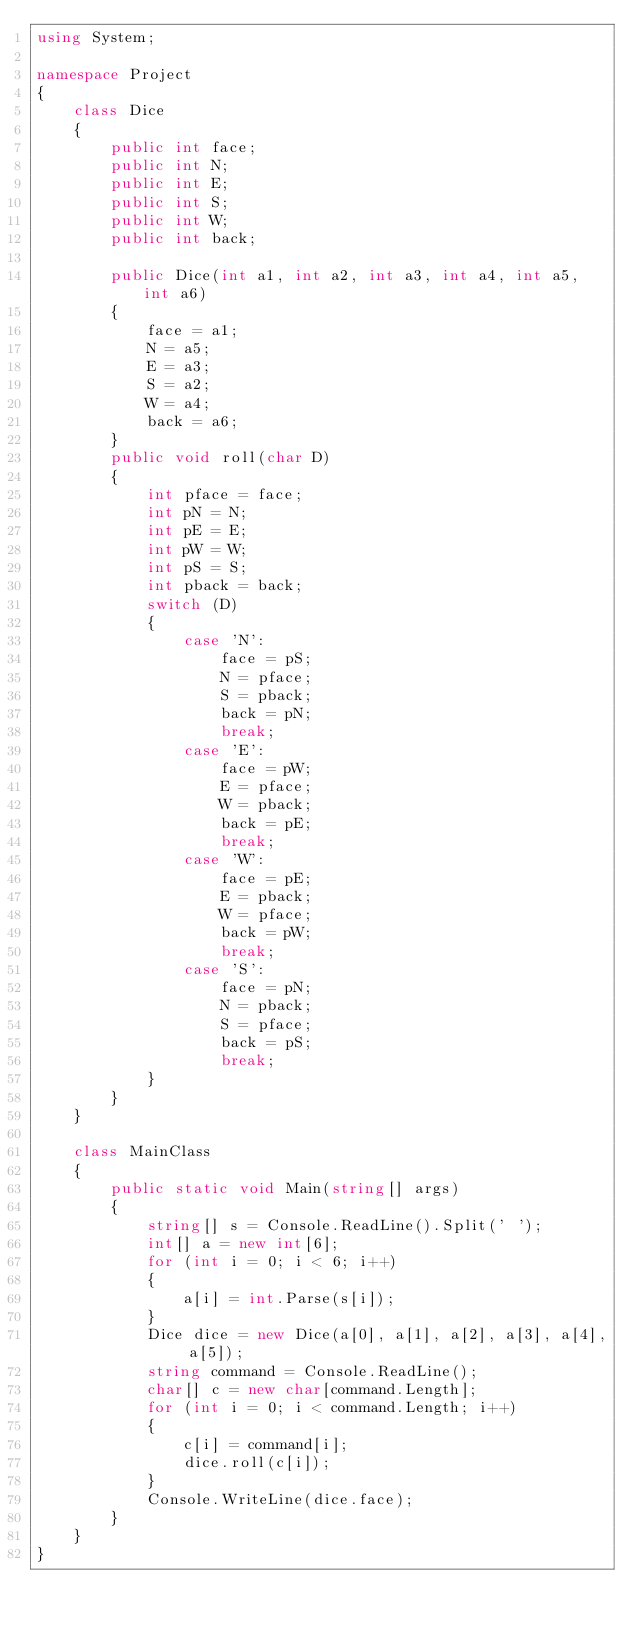<code> <loc_0><loc_0><loc_500><loc_500><_C#_>using System;

namespace Project
{
	class Dice
	{
		public int face;
		public int N;
		public int E;
		public int S;
		public int W;
		public int back;

		public Dice(int a1, int a2, int a3, int a4, int a5, int a6)
		{
			face = a1;
			N = a5;
			E = a3;
			S = a2;
			W = a4;
			back = a6;
		}
		public void roll(char D)
		{
			int pface = face;
			int pN = N;
			int pE = E;
			int pW = W;
			int pS = S;
			int pback = back;
			switch (D)
			{
				case 'N':
					face = pS;
					N = pface;
					S = pback;
					back = pN;
					break;
				case 'E':
					face = pW;
					E = pface;
					W = pback;
					back = pE;
					break;
				case 'W':
					face = pE;
					E = pback;
					W = pface;
					back = pW;
					break;
				case 'S':
					face = pN;
					N = pback;
					S = pface;
					back = pS;
					break;
			}
		}
	}

	class MainClass
	{
		public static void Main(string[] args)
		{
			string[] s = Console.ReadLine().Split(' ');
			int[] a = new int[6];
			for (int i = 0; i < 6; i++)
			{
				a[i] = int.Parse(s[i]);
			}
			Dice dice = new Dice(a[0], a[1], a[2], a[3], a[4], a[5]);
			string command = Console.ReadLine();
			char[] c = new char[command.Length];
			for (int i = 0; i < command.Length; i++)
			{
				c[i] = command[i];
				dice.roll(c[i]);
			}
			Console.WriteLine(dice.face);
		}
	}
}</code> 